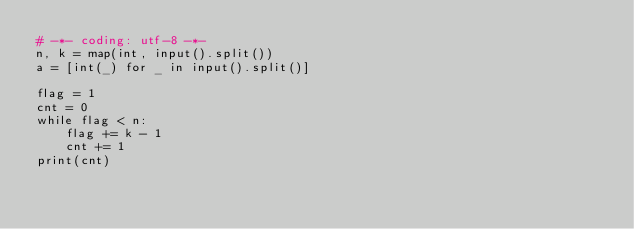Convert code to text. <code><loc_0><loc_0><loc_500><loc_500><_Python_># -*- coding: utf-8 -*-
n, k = map(int, input().split())
a = [int(_) for _ in input().split()]

flag = 1
cnt = 0
while flag < n:
    flag += k - 1
    cnt += 1
print(cnt)
</code> 